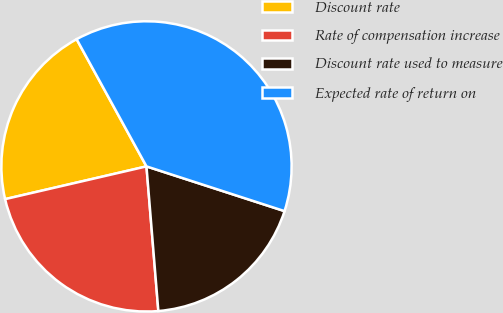<chart> <loc_0><loc_0><loc_500><loc_500><pie_chart><fcel>Discount rate<fcel>Rate of compensation increase<fcel>Discount rate used to measure<fcel>Expected rate of return on<nl><fcel>20.63%<fcel>22.68%<fcel>18.71%<fcel>37.98%<nl></chart> 